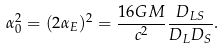<formula> <loc_0><loc_0><loc_500><loc_500>\alpha _ { 0 } ^ { 2 } = ( 2 \alpha _ { E } ) ^ { 2 } = \frac { 1 6 G M } { c ^ { 2 } } \frac { D _ { L S } } { D _ { L } D _ { S } } .</formula> 